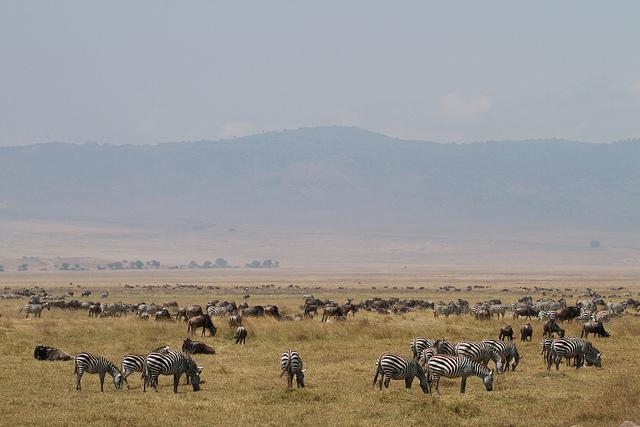Are there trees in the background?
Be succinct. No. How many zebras are in the picture?
Be succinct. 100. What type of animal is in the field?
Write a very short answer. Zebra. How many zebras are eating?
Answer briefly. 100. What's in the background?
Quick response, please. Mountains. What is the website on the photo?
Be succinct. None. How many birds are visible?
Answer briefly. 0. Are these zebras following the lone zebra in the front?
Quick response, please. No. Is the open wild?
Concise answer only. Yes. Are the animals in a zoo?
Give a very brief answer. No. What animal on the grass?
Write a very short answer. Zebra. What is this terrain like?
Short answer required. Grassy. Are any animals in the shade?
Quick response, please. No. How many zebras?
Short answer required. 14. 